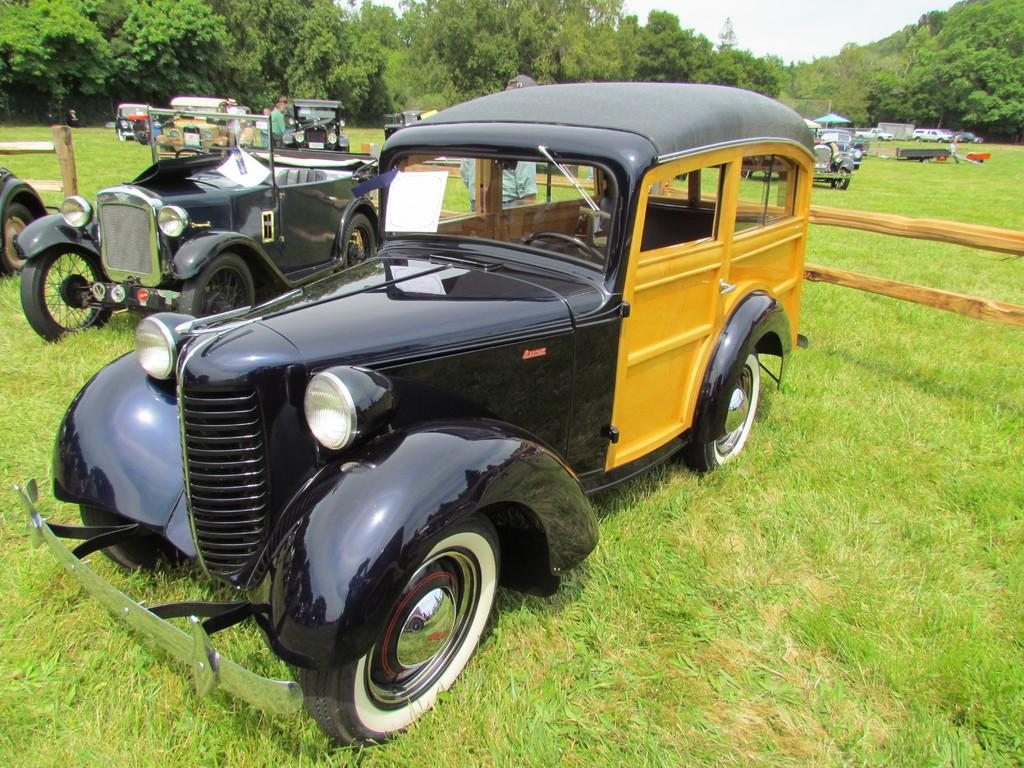What is located on the grass in the image? There are vehicles on the grass in the image. Who or what can be seen in the image besides the vehicles? There are people visible in the image. What can be seen in the background of the image? There is a tent and trees in the background of the image. What type of barrier is visible from left to right in the image? There is a wooden fence visible from left to right in the image. What type of twig is being used as a lunch utensil in the image? There is no twig being used as a lunch utensil in the image. What specific detail can be seen on the wooden fence in the image? The provided facts do not mention any specific details about the wooden fence, so we cannot answer this question definitively. 